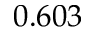<formula> <loc_0><loc_0><loc_500><loc_500>0 . 6 0 3</formula> 